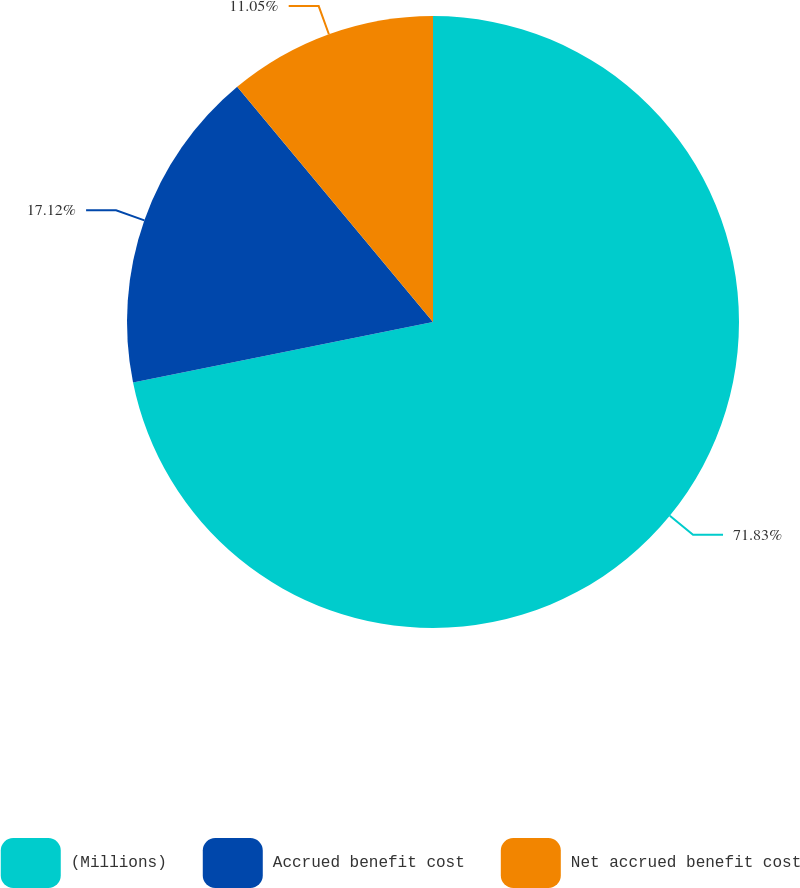Convert chart. <chart><loc_0><loc_0><loc_500><loc_500><pie_chart><fcel>(Millions)<fcel>Accrued benefit cost<fcel>Net accrued benefit cost<nl><fcel>71.83%<fcel>17.12%<fcel>11.05%<nl></chart> 